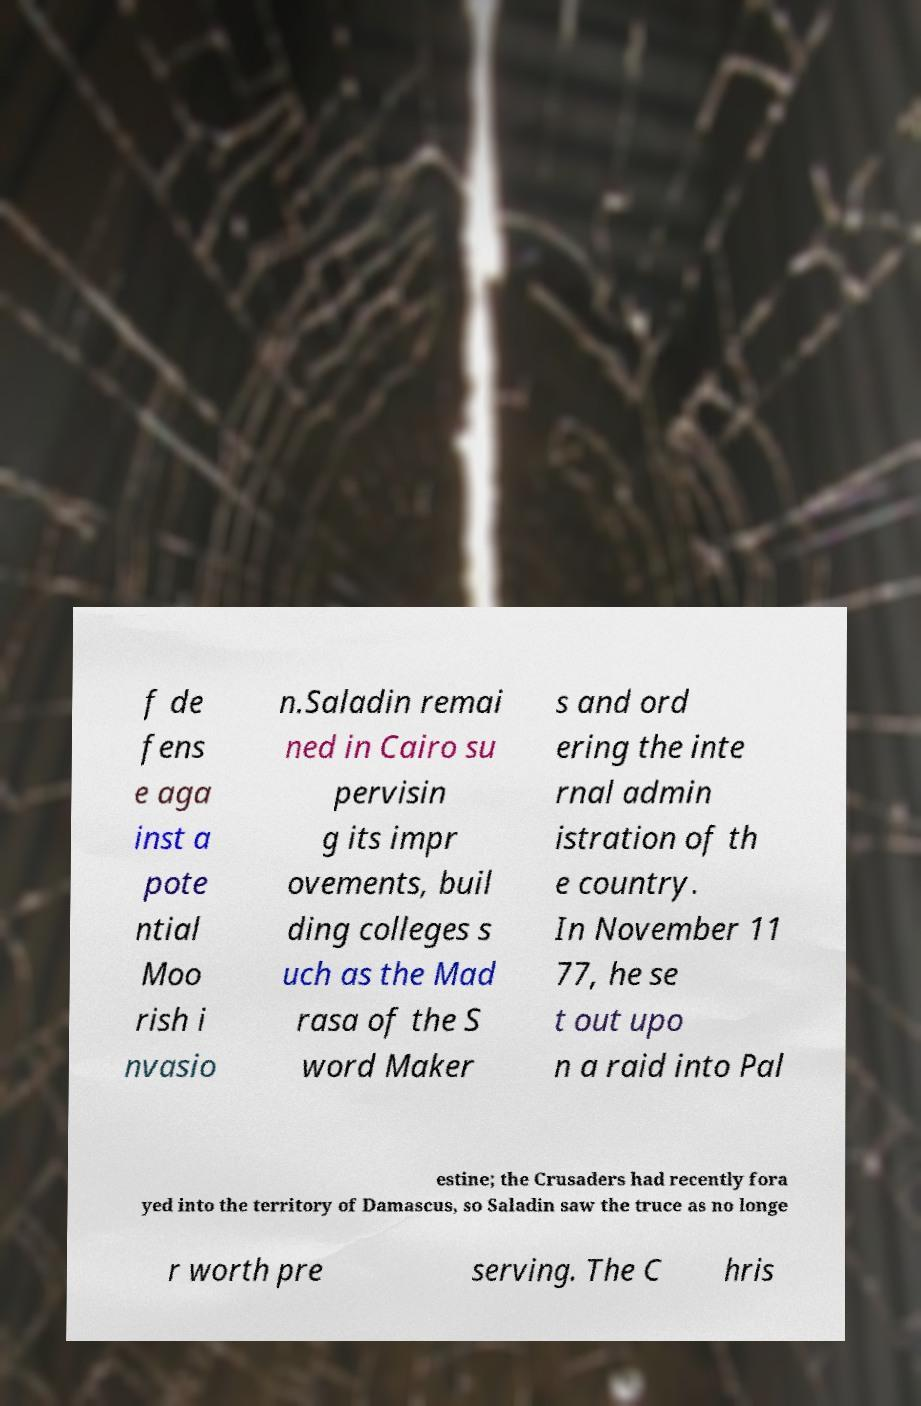Could you extract and type out the text from this image? f de fens e aga inst a pote ntial Moo rish i nvasio n.Saladin remai ned in Cairo su pervisin g its impr ovements, buil ding colleges s uch as the Mad rasa of the S word Maker s and ord ering the inte rnal admin istration of th e country. In November 11 77, he se t out upo n a raid into Pal estine; the Crusaders had recently fora yed into the territory of Damascus, so Saladin saw the truce as no longe r worth pre serving. The C hris 